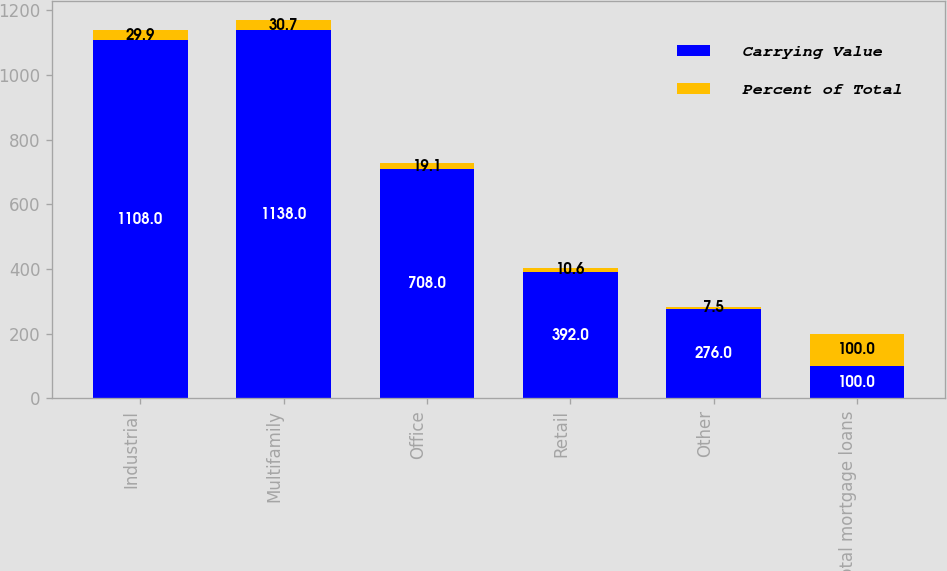Convert chart. <chart><loc_0><loc_0><loc_500><loc_500><stacked_bar_chart><ecel><fcel>Industrial<fcel>Multifamily<fcel>Office<fcel>Retail<fcel>Other<fcel>Total mortgage loans<nl><fcel>Carrying Value<fcel>1108<fcel>1138<fcel>708<fcel>392<fcel>276<fcel>100<nl><fcel>Percent of Total<fcel>29.9<fcel>30.7<fcel>19.1<fcel>10.6<fcel>7.5<fcel>100<nl></chart> 